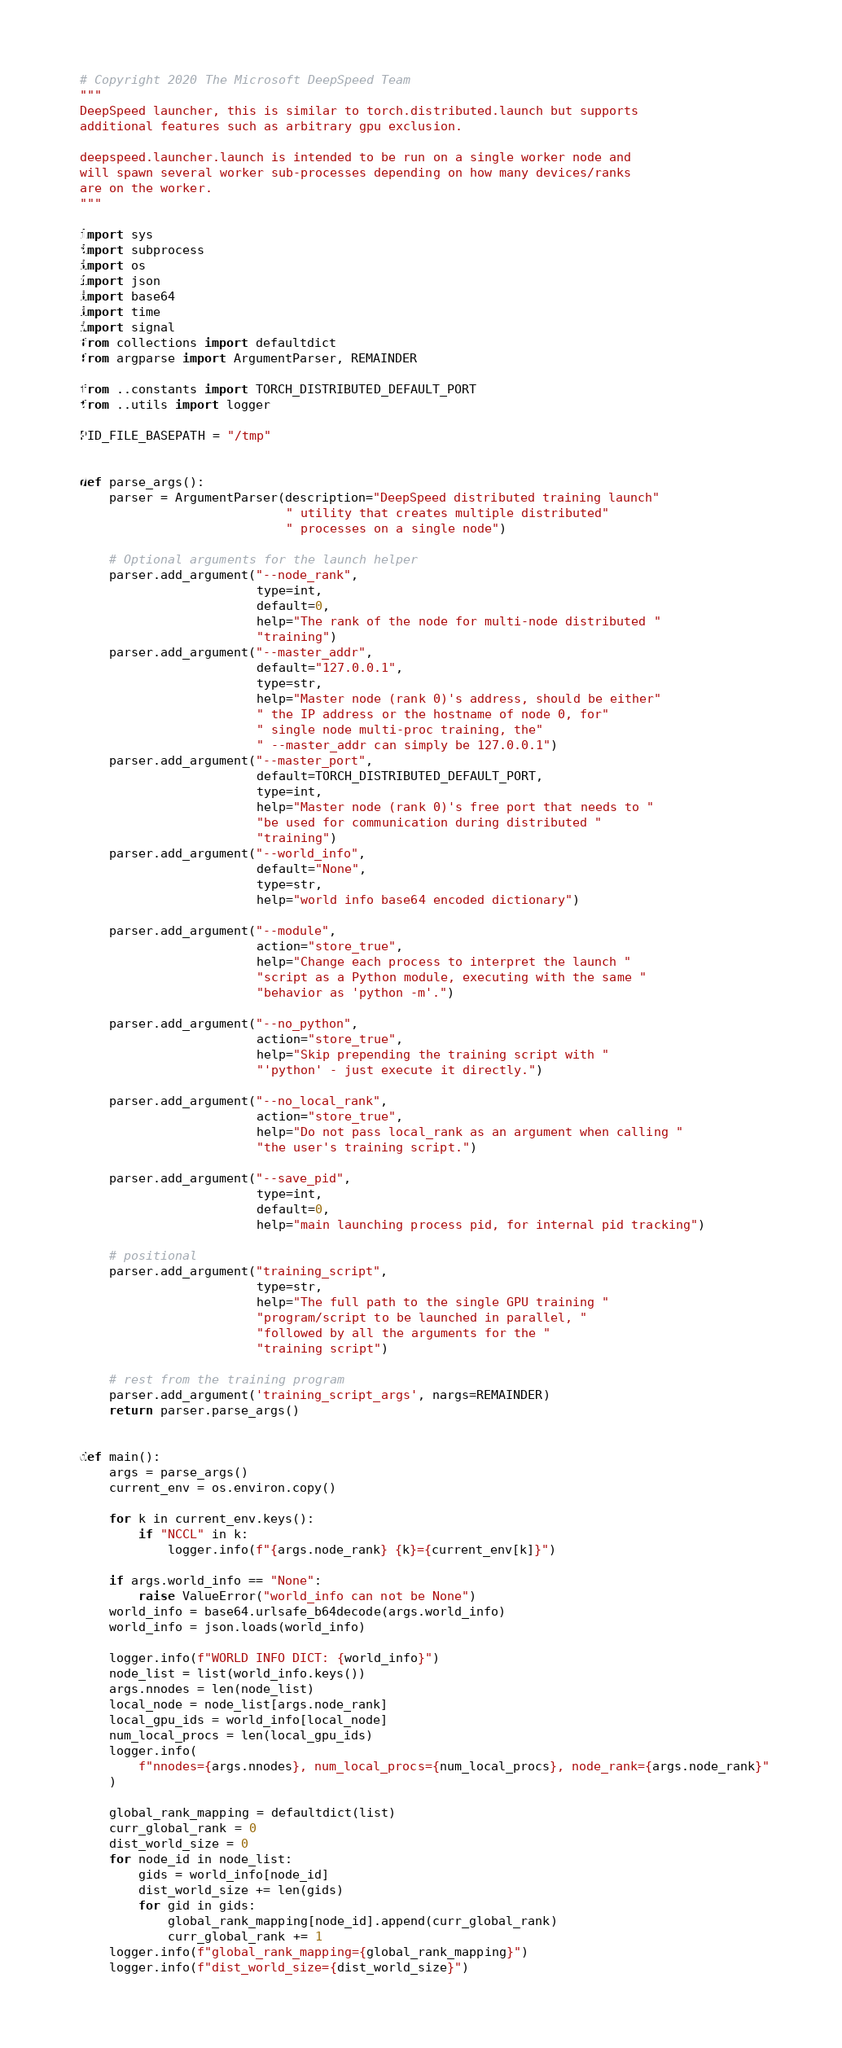<code> <loc_0><loc_0><loc_500><loc_500><_Python_># Copyright 2020 The Microsoft DeepSpeed Team
"""
DeepSpeed launcher, this is similar to torch.distributed.launch but supports
additional features such as arbitrary gpu exclusion.

deepspeed.launcher.launch is intended to be run on a single worker node and
will spawn several worker sub-processes depending on how many devices/ranks
are on the worker.
"""

import sys
import subprocess
import os
import json
import base64
import time
import signal
from collections import defaultdict
from argparse import ArgumentParser, REMAINDER

from ..constants import TORCH_DISTRIBUTED_DEFAULT_PORT
from ..utils import logger

PID_FILE_BASEPATH = "/tmp"


def parse_args():
    parser = ArgumentParser(description="DeepSpeed distributed training launch"
                            " utility that creates multiple distributed"
                            " processes on a single node")

    # Optional arguments for the launch helper
    parser.add_argument("--node_rank",
                        type=int,
                        default=0,
                        help="The rank of the node for multi-node distributed "
                        "training")
    parser.add_argument("--master_addr",
                        default="127.0.0.1",
                        type=str,
                        help="Master node (rank 0)'s address, should be either"
                        " the IP address or the hostname of node 0, for"
                        " single node multi-proc training, the"
                        " --master_addr can simply be 127.0.0.1")
    parser.add_argument("--master_port",
                        default=TORCH_DISTRIBUTED_DEFAULT_PORT,
                        type=int,
                        help="Master node (rank 0)'s free port that needs to "
                        "be used for communication during distributed "
                        "training")
    parser.add_argument("--world_info",
                        default="None",
                        type=str,
                        help="world info base64 encoded dictionary")

    parser.add_argument("--module",
                        action="store_true",
                        help="Change each process to interpret the launch "
                        "script as a Python module, executing with the same "
                        "behavior as 'python -m'.")

    parser.add_argument("--no_python",
                        action="store_true",
                        help="Skip prepending the training script with "
                        "'python' - just execute it directly.")

    parser.add_argument("--no_local_rank",
                        action="store_true",
                        help="Do not pass local_rank as an argument when calling "
                        "the user's training script.")

    parser.add_argument("--save_pid",
                        type=int,
                        default=0,
                        help="main launching process pid, for internal pid tracking")

    # positional
    parser.add_argument("training_script",
                        type=str,
                        help="The full path to the single GPU training "
                        "program/script to be launched in parallel, "
                        "followed by all the arguments for the "
                        "training script")

    # rest from the training program
    parser.add_argument('training_script_args', nargs=REMAINDER)
    return parser.parse_args()


def main():
    args = parse_args()
    current_env = os.environ.copy()

    for k in current_env.keys():
        if "NCCL" in k:
            logger.info(f"{args.node_rank} {k}={current_env[k]}")

    if args.world_info == "None":
        raise ValueError("world_info can not be None")
    world_info = base64.urlsafe_b64decode(args.world_info)
    world_info = json.loads(world_info)

    logger.info(f"WORLD INFO DICT: {world_info}")
    node_list = list(world_info.keys())
    args.nnodes = len(node_list)
    local_node = node_list[args.node_rank]
    local_gpu_ids = world_info[local_node]
    num_local_procs = len(local_gpu_ids)
    logger.info(
        f"nnodes={args.nnodes}, num_local_procs={num_local_procs}, node_rank={args.node_rank}"
    )

    global_rank_mapping = defaultdict(list)
    curr_global_rank = 0
    dist_world_size = 0
    for node_id in node_list:
        gids = world_info[node_id]
        dist_world_size += len(gids)
        for gid in gids:
            global_rank_mapping[node_id].append(curr_global_rank)
            curr_global_rank += 1
    logger.info(f"global_rank_mapping={global_rank_mapping}")
    logger.info(f"dist_world_size={dist_world_size}")</code> 